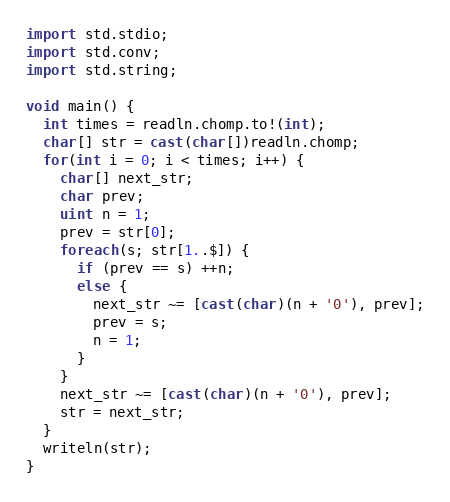<code> <loc_0><loc_0><loc_500><loc_500><_D_>
import std.stdio;
import std.conv;
import std.string;

void main() {
  int times = readln.chomp.to!(int);
  char[] str = cast(char[])readln.chomp;
  for(int i = 0; i < times; i++) {
    char[] next_str;
    char prev;
    uint n = 1;
    prev = str[0];
    foreach(s; str[1..$]) {
      if (prev == s) ++n;
      else {
        next_str ~= [cast(char)(n + '0'), prev];
        prev = s;
        n = 1;
      }
    }
    next_str ~= [cast(char)(n + '0'), prev];
    str = next_str;
  }
  writeln(str);
}</code> 